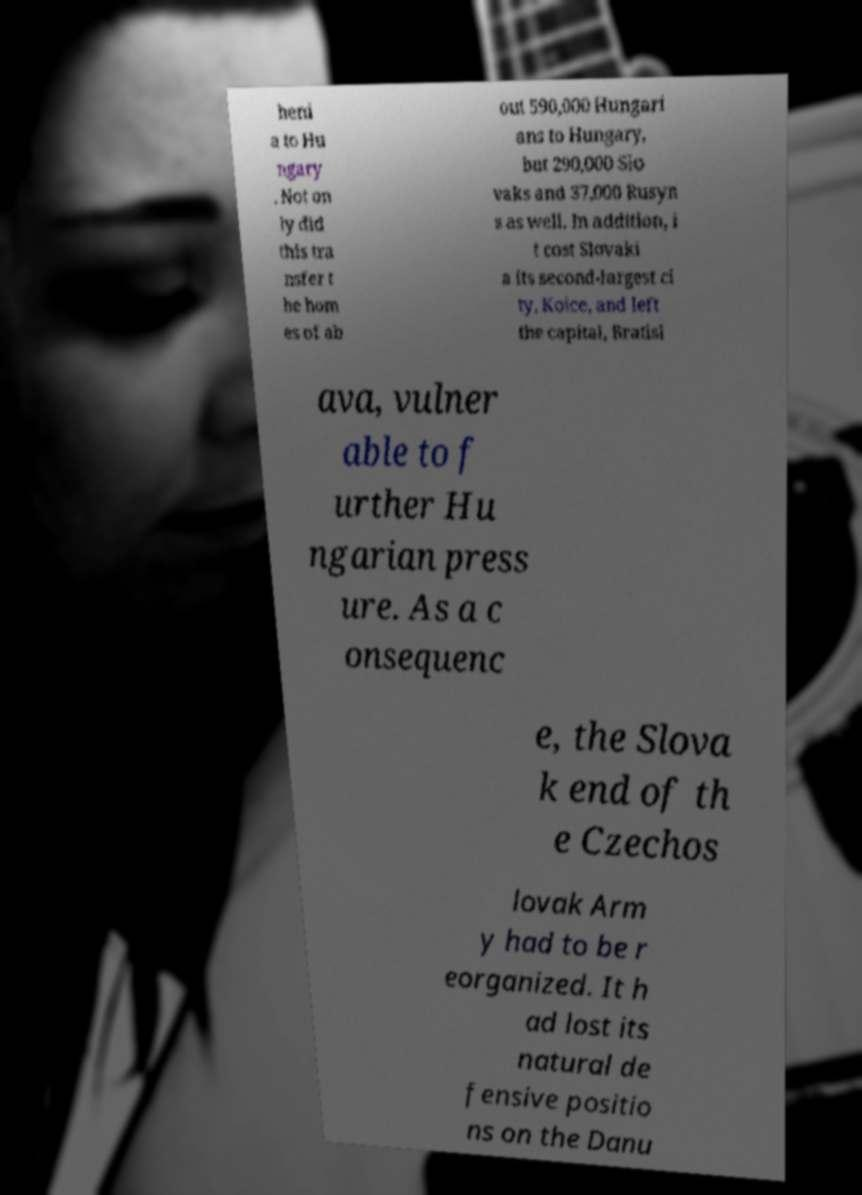For documentation purposes, I need the text within this image transcribed. Could you provide that? heni a to Hu ngary . Not on ly did this tra nsfer t he hom es of ab out 590,000 Hungari ans to Hungary, but 290,000 Slo vaks and 37,000 Rusyn s as well. In addition, i t cost Slovaki a its second-largest ci ty, Koice, and left the capital, Bratisl ava, vulner able to f urther Hu ngarian press ure. As a c onsequenc e, the Slova k end of th e Czechos lovak Arm y had to be r eorganized. It h ad lost its natural de fensive positio ns on the Danu 